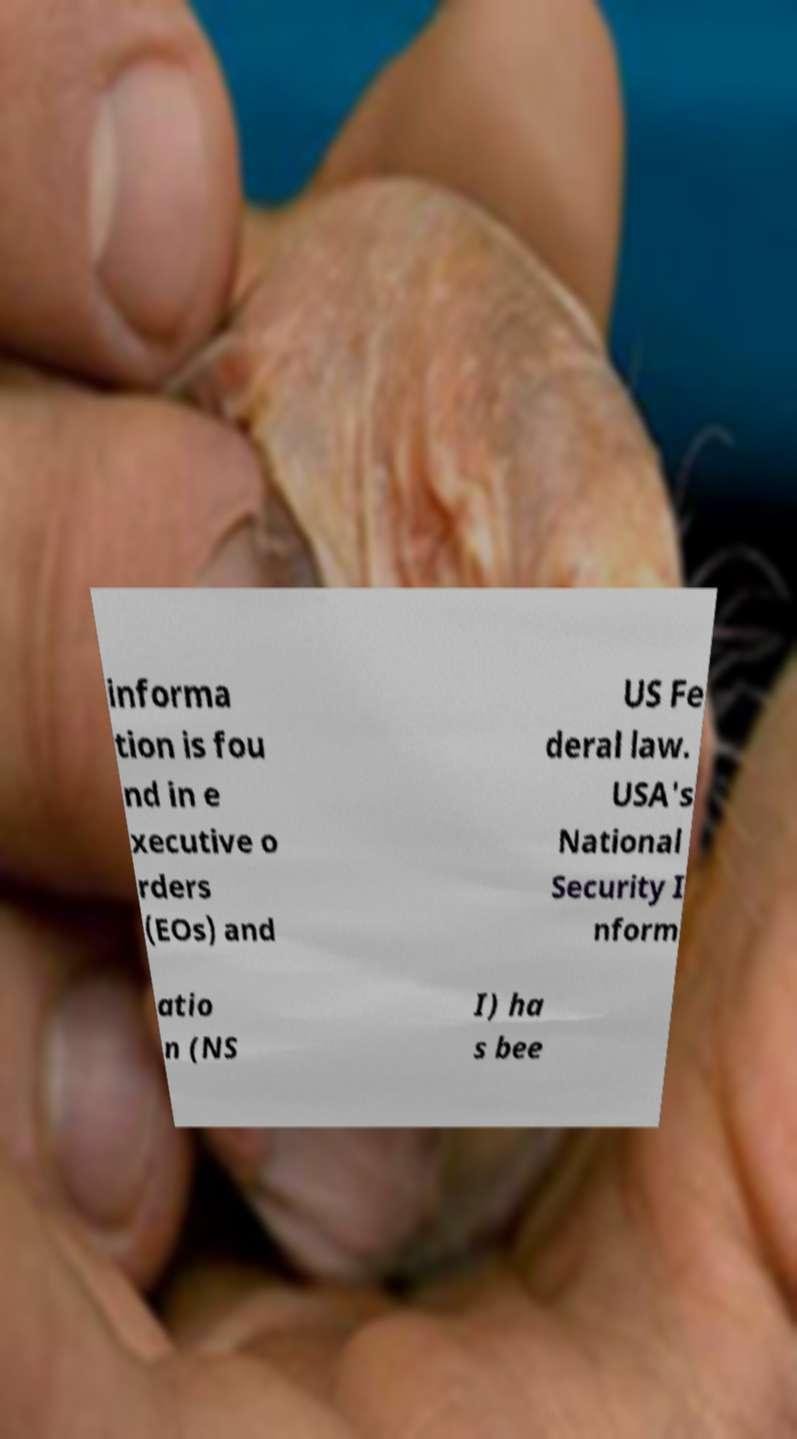For documentation purposes, I need the text within this image transcribed. Could you provide that? informa tion is fou nd in e xecutive o rders (EOs) and US Fe deral law. USA's National Security I nform atio n (NS I) ha s bee 